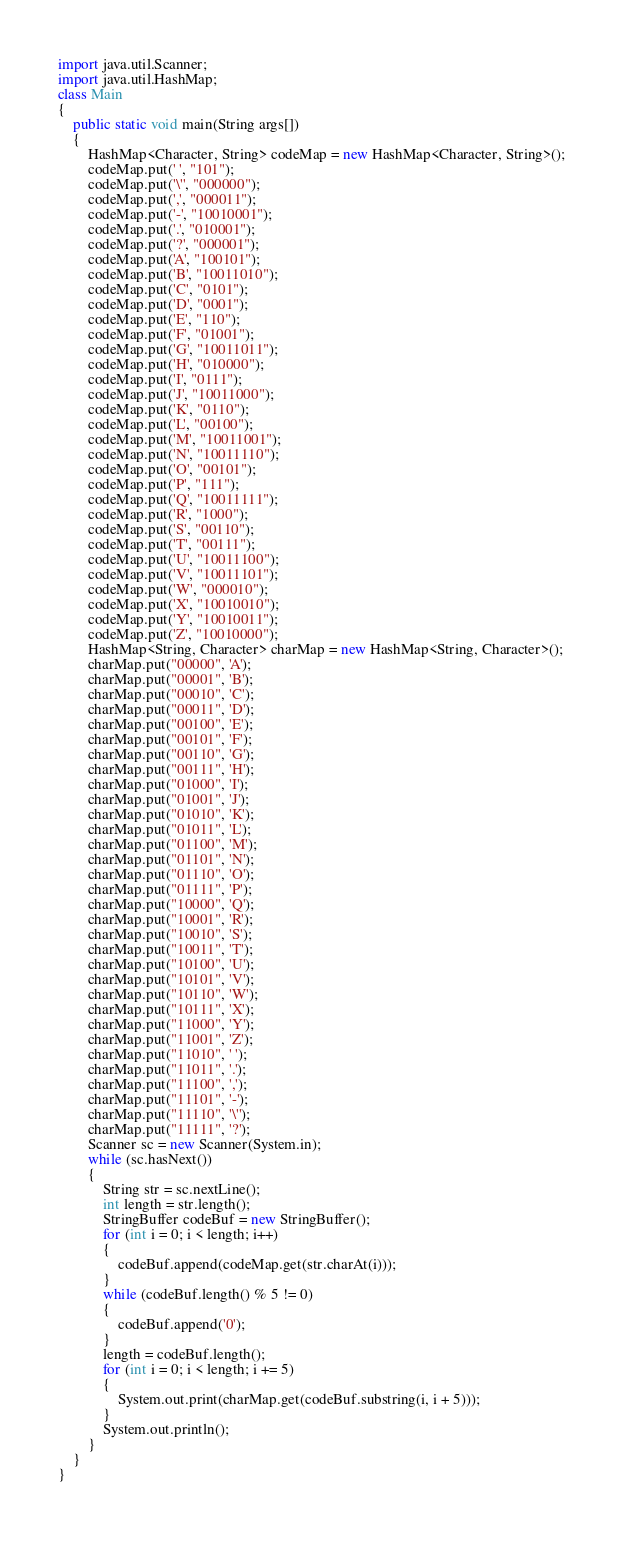Convert code to text. <code><loc_0><loc_0><loc_500><loc_500><_Java_>import java.util.Scanner;
import java.util.HashMap;
class Main
{
	public static void main(String args[])
	{
		HashMap<Character, String> codeMap = new HashMap<Character, String>();
		codeMap.put(' ', "101");
		codeMap.put('\'', "000000");
		codeMap.put(',', "000011");
		codeMap.put('-', "10010001");
		codeMap.put('.', "010001");
		codeMap.put('?', "000001");
		codeMap.put('A', "100101");
		codeMap.put('B', "10011010");
		codeMap.put('C', "0101");
		codeMap.put('D', "0001");
		codeMap.put('E', "110");
		codeMap.put('F', "01001");
		codeMap.put('G', "10011011");
		codeMap.put('H', "010000");
		codeMap.put('I', "0111");
		codeMap.put('J', "10011000");
		codeMap.put('K', "0110");
		codeMap.put('L', "00100");
		codeMap.put('M', "10011001");
		codeMap.put('N', "10011110");
		codeMap.put('O', "00101");
		codeMap.put('P', "111");
		codeMap.put('Q', "10011111");
		codeMap.put('R', "1000");
		codeMap.put('S', "00110");
		codeMap.put('T', "00111");
		codeMap.put('U', "10011100");
		codeMap.put('V', "10011101");
		codeMap.put('W', "000010");
		codeMap.put('X', "10010010");
		codeMap.put('Y', "10010011");
		codeMap.put('Z', "10010000");
		HashMap<String, Character> charMap = new HashMap<String, Character>();
		charMap.put("00000", 'A');
		charMap.put("00001", 'B');
		charMap.put("00010", 'C');
		charMap.put("00011", 'D');
		charMap.put("00100", 'E');
		charMap.put("00101", 'F');
		charMap.put("00110", 'G');
		charMap.put("00111", 'H');
		charMap.put("01000", 'I');
		charMap.put("01001", 'J');
		charMap.put("01010", 'K');
		charMap.put("01011", 'L');
		charMap.put("01100", 'M');
		charMap.put("01101", 'N');
		charMap.put("01110", 'O');
		charMap.put("01111", 'P');
		charMap.put("10000", 'Q');
		charMap.put("10001", 'R');
		charMap.put("10010", 'S');
		charMap.put("10011", 'T');
		charMap.put("10100", 'U');
		charMap.put("10101", 'V');
		charMap.put("10110", 'W');
		charMap.put("10111", 'X');
		charMap.put("11000", 'Y');
		charMap.put("11001", 'Z');
		charMap.put("11010", ' ');
		charMap.put("11011", '.');
		charMap.put("11100", ',');
		charMap.put("11101", '-');
		charMap.put("11110", '\'');
		charMap.put("11111", '?');
		Scanner sc = new Scanner(System.in);
		while (sc.hasNext())
		{
			String str = sc.nextLine();
			int length = str.length();
			StringBuffer codeBuf = new StringBuffer();
			for (int i = 0; i < length; i++)
			{
				codeBuf.append(codeMap.get(str.charAt(i)));
			}
			while (codeBuf.length() % 5 != 0)
			{
				codeBuf.append('0');
			}
			length = codeBuf.length();
			for (int i = 0; i < length; i += 5)
			{
				System.out.print(charMap.get(codeBuf.substring(i, i + 5)));
			}
			System.out.println();
		}
	}
}</code> 